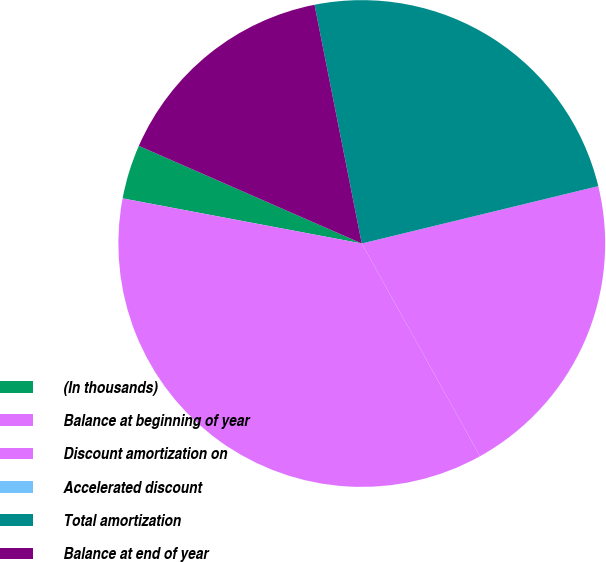Convert chart to OTSL. <chart><loc_0><loc_0><loc_500><loc_500><pie_chart><fcel>(In thousands)<fcel>Balance at beginning of year<fcel>Discount amortization on<fcel>Accelerated discount<fcel>Total amortization<fcel>Balance at end of year<nl><fcel>3.6%<fcel>36.04%<fcel>20.71%<fcel>0.0%<fcel>24.32%<fcel>15.32%<nl></chart> 